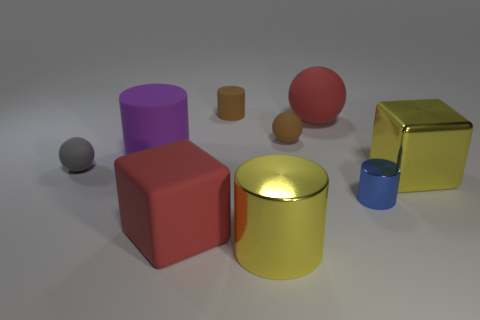What number of purple things are the same size as the blue cylinder?
Your response must be concise. 0. What is the red ball made of?
Make the answer very short. Rubber. Do the large shiny cylinder and the big block to the left of the tiny brown rubber ball have the same color?
Ensure brevity in your answer.  No. How big is the rubber sphere that is both in front of the big sphere and on the right side of the small gray sphere?
Your response must be concise. Small. There is a tiny gray object that is made of the same material as the purple object; what is its shape?
Your answer should be compact. Sphere. Is the material of the gray ball the same as the yellow object that is in front of the yellow cube?
Provide a short and direct response. No. Are there any tiny rubber cylinders that are on the left side of the brown thing that is on the left side of the large yellow metallic cylinder?
Offer a very short reply. No. There is a big yellow thing that is the same shape as the small blue object; what is it made of?
Your response must be concise. Metal. What number of small gray spheres are to the right of the large rubber thing that is on the right side of the brown rubber cylinder?
Make the answer very short. 0. Is there any other thing that has the same color as the shiny block?
Ensure brevity in your answer.  Yes. 